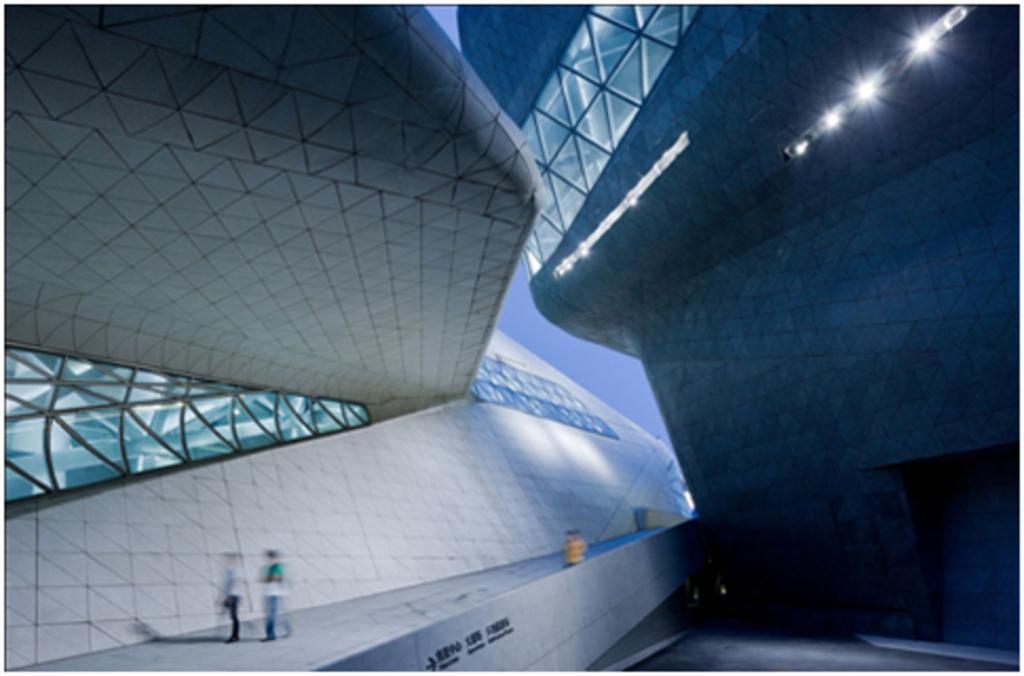In one or two sentences, can you explain what this image depicts? There are two buildings with a glass windows are present in the middle of this image, and there are some persons present at the bottom of this image. We can see there is a sky in the background. 